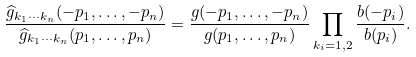Convert formula to latex. <formula><loc_0><loc_0><loc_500><loc_500>\frac { { \widehat { g } } _ { k _ { 1 } \cdots k _ { n } } ( - p _ { 1 } , \dots , - p _ { n } ) } { { \widehat { g } } _ { k _ { 1 } \cdots k _ { n } } ( p _ { 1 } , \dots , p _ { n } ) } = \frac { g ( - p _ { 1 } , \dots , - p _ { n } ) } { g ( p _ { 1 } , \dots , p _ { n } ) } \prod _ { k _ { i } = 1 , 2 } \frac { b ( - p _ { i } ) } { b ( p _ { i } ) } .</formula> 